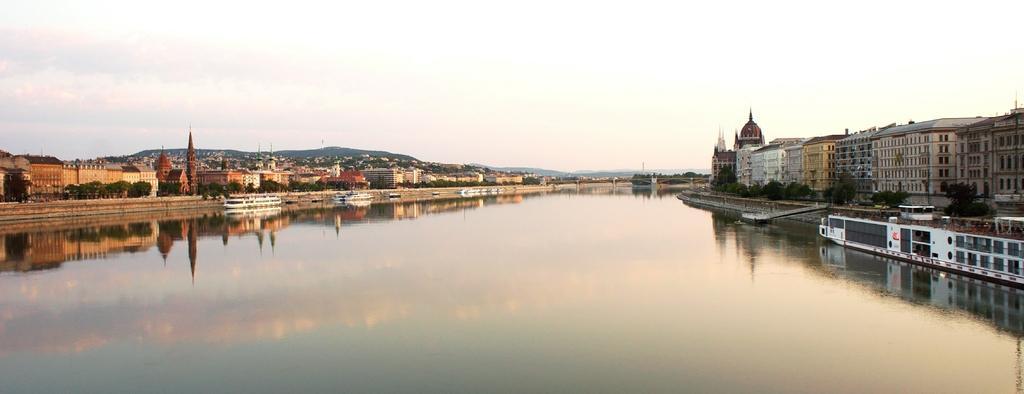Describe this image in one or two sentences. In this image, we can see a river in between buildings. There is a boat on the right side of the image. There is a sky at the top of the image. 